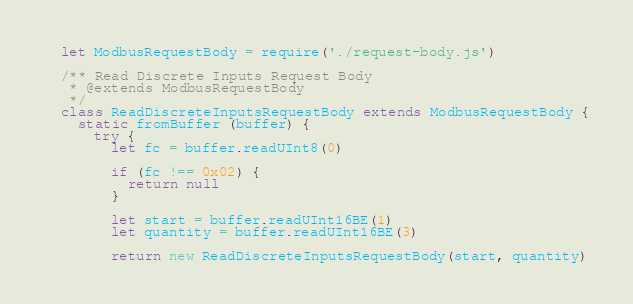<code> <loc_0><loc_0><loc_500><loc_500><_JavaScript_>  let ModbusRequestBody = require('./request-body.js')

  /** Read Discrete Inputs Request Body
   * @extends ModbusRequestBody
   */
  class ReadDiscreteInputsRequestBody extends ModbusRequestBody {
    static fromBuffer (buffer) {
      try {
        let fc = buffer.readUInt8(0)

        if (fc !== 0x02) {
          return null
        }

        let start = buffer.readUInt16BE(1)
        let quantity = buffer.readUInt16BE(3)

        return new ReadDiscreteInputsRequestBody(start, quantity)</code> 